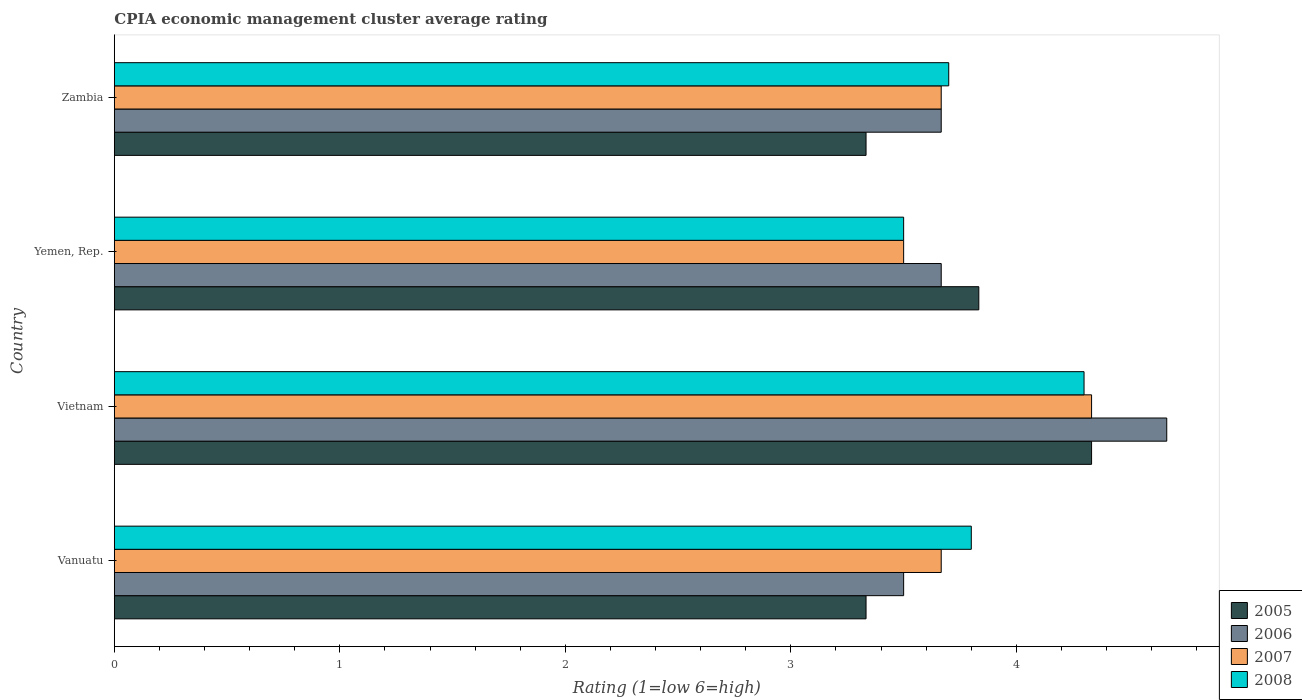Are the number of bars per tick equal to the number of legend labels?
Your response must be concise. Yes. Are the number of bars on each tick of the Y-axis equal?
Offer a terse response. Yes. How many bars are there on the 4th tick from the bottom?
Provide a succinct answer. 4. What is the label of the 3rd group of bars from the top?
Give a very brief answer. Vietnam. In how many cases, is the number of bars for a given country not equal to the number of legend labels?
Provide a short and direct response. 0. What is the CPIA rating in 2006 in Yemen, Rep.?
Offer a terse response. 3.67. Across all countries, what is the maximum CPIA rating in 2008?
Keep it short and to the point. 4.3. Across all countries, what is the minimum CPIA rating in 2006?
Offer a very short reply. 3.5. In which country was the CPIA rating in 2005 maximum?
Give a very brief answer. Vietnam. In which country was the CPIA rating in 2005 minimum?
Give a very brief answer. Vanuatu. What is the total CPIA rating in 2006 in the graph?
Offer a terse response. 15.5. What is the difference between the CPIA rating in 2005 in Yemen, Rep. and that in Zambia?
Make the answer very short. 0.5. What is the difference between the CPIA rating in 2005 in Vietnam and the CPIA rating in 2007 in Vanuatu?
Offer a terse response. 0.67. What is the average CPIA rating in 2007 per country?
Offer a very short reply. 3.79. What is the difference between the CPIA rating in 2005 and CPIA rating in 2008 in Zambia?
Keep it short and to the point. -0.37. In how many countries, is the CPIA rating in 2005 greater than 4.4 ?
Offer a terse response. 0. What is the ratio of the CPIA rating in 2006 in Yemen, Rep. to that in Zambia?
Your answer should be compact. 1. Is the CPIA rating in 2007 in Vietnam less than that in Zambia?
Offer a terse response. No. What is the difference between the highest and the second highest CPIA rating in 2007?
Offer a terse response. 0.67. What is the difference between the highest and the lowest CPIA rating in 2007?
Offer a very short reply. 0.83. Is the sum of the CPIA rating in 2005 in Vanuatu and Yemen, Rep. greater than the maximum CPIA rating in 2007 across all countries?
Your response must be concise. Yes. Is it the case that in every country, the sum of the CPIA rating in 2006 and CPIA rating in 2007 is greater than the sum of CPIA rating in 2008 and CPIA rating in 2005?
Give a very brief answer. No. What does the 2nd bar from the bottom in Yemen, Rep. represents?
Offer a terse response. 2006. Is it the case that in every country, the sum of the CPIA rating in 2008 and CPIA rating in 2006 is greater than the CPIA rating in 2005?
Provide a short and direct response. Yes. Are all the bars in the graph horizontal?
Offer a very short reply. Yes. Does the graph contain any zero values?
Give a very brief answer. No. Where does the legend appear in the graph?
Keep it short and to the point. Bottom right. How are the legend labels stacked?
Give a very brief answer. Vertical. What is the title of the graph?
Ensure brevity in your answer.  CPIA economic management cluster average rating. Does "2008" appear as one of the legend labels in the graph?
Your answer should be compact. Yes. What is the label or title of the X-axis?
Provide a succinct answer. Rating (1=low 6=high). What is the Rating (1=low 6=high) in 2005 in Vanuatu?
Your answer should be very brief. 3.33. What is the Rating (1=low 6=high) in 2006 in Vanuatu?
Keep it short and to the point. 3.5. What is the Rating (1=low 6=high) in 2007 in Vanuatu?
Your answer should be very brief. 3.67. What is the Rating (1=low 6=high) in 2008 in Vanuatu?
Ensure brevity in your answer.  3.8. What is the Rating (1=low 6=high) of 2005 in Vietnam?
Your answer should be compact. 4.33. What is the Rating (1=low 6=high) of 2006 in Vietnam?
Give a very brief answer. 4.67. What is the Rating (1=low 6=high) of 2007 in Vietnam?
Make the answer very short. 4.33. What is the Rating (1=low 6=high) of 2008 in Vietnam?
Your answer should be very brief. 4.3. What is the Rating (1=low 6=high) in 2005 in Yemen, Rep.?
Ensure brevity in your answer.  3.83. What is the Rating (1=low 6=high) of 2006 in Yemen, Rep.?
Offer a very short reply. 3.67. What is the Rating (1=low 6=high) in 2007 in Yemen, Rep.?
Ensure brevity in your answer.  3.5. What is the Rating (1=low 6=high) in 2008 in Yemen, Rep.?
Offer a terse response. 3.5. What is the Rating (1=low 6=high) in 2005 in Zambia?
Your response must be concise. 3.33. What is the Rating (1=low 6=high) in 2006 in Zambia?
Provide a succinct answer. 3.67. What is the Rating (1=low 6=high) in 2007 in Zambia?
Offer a terse response. 3.67. What is the Rating (1=low 6=high) in 2008 in Zambia?
Offer a terse response. 3.7. Across all countries, what is the maximum Rating (1=low 6=high) of 2005?
Offer a very short reply. 4.33. Across all countries, what is the maximum Rating (1=low 6=high) in 2006?
Your answer should be compact. 4.67. Across all countries, what is the maximum Rating (1=low 6=high) in 2007?
Your answer should be very brief. 4.33. Across all countries, what is the maximum Rating (1=low 6=high) of 2008?
Your response must be concise. 4.3. Across all countries, what is the minimum Rating (1=low 6=high) of 2005?
Provide a short and direct response. 3.33. What is the total Rating (1=low 6=high) in 2005 in the graph?
Ensure brevity in your answer.  14.83. What is the total Rating (1=low 6=high) in 2007 in the graph?
Keep it short and to the point. 15.17. What is the difference between the Rating (1=low 6=high) in 2005 in Vanuatu and that in Vietnam?
Provide a short and direct response. -1. What is the difference between the Rating (1=low 6=high) of 2006 in Vanuatu and that in Vietnam?
Your response must be concise. -1.17. What is the difference between the Rating (1=low 6=high) in 2008 in Vanuatu and that in Vietnam?
Give a very brief answer. -0.5. What is the difference between the Rating (1=low 6=high) in 2005 in Vanuatu and that in Yemen, Rep.?
Offer a terse response. -0.5. What is the difference between the Rating (1=low 6=high) of 2006 in Vanuatu and that in Yemen, Rep.?
Ensure brevity in your answer.  -0.17. What is the difference between the Rating (1=low 6=high) of 2007 in Vanuatu and that in Yemen, Rep.?
Ensure brevity in your answer.  0.17. What is the difference between the Rating (1=low 6=high) in 2008 in Vanuatu and that in Yemen, Rep.?
Give a very brief answer. 0.3. What is the difference between the Rating (1=low 6=high) of 2006 in Vanuatu and that in Zambia?
Your answer should be very brief. -0.17. What is the difference between the Rating (1=low 6=high) of 2007 in Vanuatu and that in Zambia?
Offer a very short reply. 0. What is the difference between the Rating (1=low 6=high) of 2005 in Vietnam and that in Yemen, Rep.?
Your response must be concise. 0.5. What is the difference between the Rating (1=low 6=high) of 2006 in Vietnam and that in Zambia?
Make the answer very short. 1. What is the difference between the Rating (1=low 6=high) of 2007 in Vietnam and that in Zambia?
Ensure brevity in your answer.  0.67. What is the difference between the Rating (1=low 6=high) of 2005 in Yemen, Rep. and that in Zambia?
Your answer should be very brief. 0.5. What is the difference between the Rating (1=low 6=high) in 2006 in Yemen, Rep. and that in Zambia?
Your response must be concise. 0. What is the difference between the Rating (1=low 6=high) of 2007 in Yemen, Rep. and that in Zambia?
Ensure brevity in your answer.  -0.17. What is the difference between the Rating (1=low 6=high) in 2005 in Vanuatu and the Rating (1=low 6=high) in 2006 in Vietnam?
Provide a succinct answer. -1.33. What is the difference between the Rating (1=low 6=high) in 2005 in Vanuatu and the Rating (1=low 6=high) in 2007 in Vietnam?
Keep it short and to the point. -1. What is the difference between the Rating (1=low 6=high) of 2005 in Vanuatu and the Rating (1=low 6=high) of 2008 in Vietnam?
Your answer should be very brief. -0.97. What is the difference between the Rating (1=low 6=high) in 2006 in Vanuatu and the Rating (1=low 6=high) in 2008 in Vietnam?
Provide a succinct answer. -0.8. What is the difference between the Rating (1=low 6=high) of 2007 in Vanuatu and the Rating (1=low 6=high) of 2008 in Vietnam?
Make the answer very short. -0.63. What is the difference between the Rating (1=low 6=high) of 2005 in Vanuatu and the Rating (1=low 6=high) of 2006 in Yemen, Rep.?
Your answer should be very brief. -0.33. What is the difference between the Rating (1=low 6=high) of 2005 in Vanuatu and the Rating (1=low 6=high) of 2008 in Yemen, Rep.?
Keep it short and to the point. -0.17. What is the difference between the Rating (1=low 6=high) in 2005 in Vanuatu and the Rating (1=low 6=high) in 2008 in Zambia?
Your answer should be compact. -0.37. What is the difference between the Rating (1=low 6=high) of 2006 in Vanuatu and the Rating (1=low 6=high) of 2008 in Zambia?
Your answer should be compact. -0.2. What is the difference between the Rating (1=low 6=high) of 2007 in Vanuatu and the Rating (1=low 6=high) of 2008 in Zambia?
Keep it short and to the point. -0.03. What is the difference between the Rating (1=low 6=high) of 2005 in Vietnam and the Rating (1=low 6=high) of 2007 in Yemen, Rep.?
Make the answer very short. 0.83. What is the difference between the Rating (1=low 6=high) of 2005 in Vietnam and the Rating (1=low 6=high) of 2008 in Yemen, Rep.?
Ensure brevity in your answer.  0.83. What is the difference between the Rating (1=low 6=high) in 2005 in Vietnam and the Rating (1=low 6=high) in 2006 in Zambia?
Ensure brevity in your answer.  0.67. What is the difference between the Rating (1=low 6=high) in 2005 in Vietnam and the Rating (1=low 6=high) in 2008 in Zambia?
Keep it short and to the point. 0.63. What is the difference between the Rating (1=low 6=high) in 2006 in Vietnam and the Rating (1=low 6=high) in 2008 in Zambia?
Make the answer very short. 0.97. What is the difference between the Rating (1=low 6=high) of 2007 in Vietnam and the Rating (1=low 6=high) of 2008 in Zambia?
Offer a very short reply. 0.63. What is the difference between the Rating (1=low 6=high) of 2005 in Yemen, Rep. and the Rating (1=low 6=high) of 2006 in Zambia?
Offer a very short reply. 0.17. What is the difference between the Rating (1=low 6=high) of 2005 in Yemen, Rep. and the Rating (1=low 6=high) of 2007 in Zambia?
Offer a very short reply. 0.17. What is the difference between the Rating (1=low 6=high) of 2005 in Yemen, Rep. and the Rating (1=low 6=high) of 2008 in Zambia?
Keep it short and to the point. 0.13. What is the difference between the Rating (1=low 6=high) in 2006 in Yemen, Rep. and the Rating (1=low 6=high) in 2008 in Zambia?
Your response must be concise. -0.03. What is the average Rating (1=low 6=high) of 2005 per country?
Keep it short and to the point. 3.71. What is the average Rating (1=low 6=high) in 2006 per country?
Provide a short and direct response. 3.88. What is the average Rating (1=low 6=high) of 2007 per country?
Provide a short and direct response. 3.79. What is the average Rating (1=low 6=high) of 2008 per country?
Your answer should be compact. 3.83. What is the difference between the Rating (1=low 6=high) of 2005 and Rating (1=low 6=high) of 2007 in Vanuatu?
Your response must be concise. -0.33. What is the difference between the Rating (1=low 6=high) of 2005 and Rating (1=low 6=high) of 2008 in Vanuatu?
Make the answer very short. -0.47. What is the difference between the Rating (1=low 6=high) of 2006 and Rating (1=low 6=high) of 2008 in Vanuatu?
Provide a short and direct response. -0.3. What is the difference between the Rating (1=low 6=high) of 2007 and Rating (1=low 6=high) of 2008 in Vanuatu?
Your answer should be very brief. -0.13. What is the difference between the Rating (1=low 6=high) of 2005 and Rating (1=low 6=high) of 2007 in Vietnam?
Offer a terse response. 0. What is the difference between the Rating (1=low 6=high) in 2006 and Rating (1=low 6=high) in 2007 in Vietnam?
Offer a very short reply. 0.33. What is the difference between the Rating (1=low 6=high) of 2006 and Rating (1=low 6=high) of 2008 in Vietnam?
Your answer should be very brief. 0.37. What is the difference between the Rating (1=low 6=high) in 2005 and Rating (1=low 6=high) in 2007 in Yemen, Rep.?
Your answer should be very brief. 0.33. What is the difference between the Rating (1=low 6=high) in 2005 and Rating (1=low 6=high) in 2008 in Yemen, Rep.?
Make the answer very short. 0.33. What is the difference between the Rating (1=low 6=high) of 2006 and Rating (1=low 6=high) of 2007 in Yemen, Rep.?
Provide a short and direct response. 0.17. What is the difference between the Rating (1=low 6=high) of 2006 and Rating (1=low 6=high) of 2008 in Yemen, Rep.?
Your answer should be compact. 0.17. What is the difference between the Rating (1=low 6=high) of 2007 and Rating (1=low 6=high) of 2008 in Yemen, Rep.?
Keep it short and to the point. 0. What is the difference between the Rating (1=low 6=high) in 2005 and Rating (1=low 6=high) in 2006 in Zambia?
Offer a terse response. -0.33. What is the difference between the Rating (1=low 6=high) in 2005 and Rating (1=low 6=high) in 2007 in Zambia?
Provide a short and direct response. -0.33. What is the difference between the Rating (1=low 6=high) of 2005 and Rating (1=low 6=high) of 2008 in Zambia?
Make the answer very short. -0.37. What is the difference between the Rating (1=low 6=high) in 2006 and Rating (1=low 6=high) in 2008 in Zambia?
Provide a short and direct response. -0.03. What is the difference between the Rating (1=low 6=high) in 2007 and Rating (1=low 6=high) in 2008 in Zambia?
Ensure brevity in your answer.  -0.03. What is the ratio of the Rating (1=low 6=high) of 2005 in Vanuatu to that in Vietnam?
Provide a succinct answer. 0.77. What is the ratio of the Rating (1=low 6=high) of 2006 in Vanuatu to that in Vietnam?
Make the answer very short. 0.75. What is the ratio of the Rating (1=low 6=high) in 2007 in Vanuatu to that in Vietnam?
Give a very brief answer. 0.85. What is the ratio of the Rating (1=low 6=high) of 2008 in Vanuatu to that in Vietnam?
Your answer should be very brief. 0.88. What is the ratio of the Rating (1=low 6=high) of 2005 in Vanuatu to that in Yemen, Rep.?
Your answer should be very brief. 0.87. What is the ratio of the Rating (1=low 6=high) in 2006 in Vanuatu to that in Yemen, Rep.?
Provide a succinct answer. 0.95. What is the ratio of the Rating (1=low 6=high) of 2007 in Vanuatu to that in Yemen, Rep.?
Offer a terse response. 1.05. What is the ratio of the Rating (1=low 6=high) in 2008 in Vanuatu to that in Yemen, Rep.?
Offer a very short reply. 1.09. What is the ratio of the Rating (1=low 6=high) of 2006 in Vanuatu to that in Zambia?
Ensure brevity in your answer.  0.95. What is the ratio of the Rating (1=low 6=high) of 2005 in Vietnam to that in Yemen, Rep.?
Ensure brevity in your answer.  1.13. What is the ratio of the Rating (1=low 6=high) in 2006 in Vietnam to that in Yemen, Rep.?
Your response must be concise. 1.27. What is the ratio of the Rating (1=low 6=high) of 2007 in Vietnam to that in Yemen, Rep.?
Make the answer very short. 1.24. What is the ratio of the Rating (1=low 6=high) of 2008 in Vietnam to that in Yemen, Rep.?
Your answer should be compact. 1.23. What is the ratio of the Rating (1=low 6=high) in 2005 in Vietnam to that in Zambia?
Keep it short and to the point. 1.3. What is the ratio of the Rating (1=low 6=high) of 2006 in Vietnam to that in Zambia?
Your response must be concise. 1.27. What is the ratio of the Rating (1=low 6=high) in 2007 in Vietnam to that in Zambia?
Offer a very short reply. 1.18. What is the ratio of the Rating (1=low 6=high) in 2008 in Vietnam to that in Zambia?
Give a very brief answer. 1.16. What is the ratio of the Rating (1=low 6=high) of 2005 in Yemen, Rep. to that in Zambia?
Give a very brief answer. 1.15. What is the ratio of the Rating (1=low 6=high) of 2007 in Yemen, Rep. to that in Zambia?
Your response must be concise. 0.95. What is the ratio of the Rating (1=low 6=high) of 2008 in Yemen, Rep. to that in Zambia?
Ensure brevity in your answer.  0.95. What is the difference between the highest and the second highest Rating (1=low 6=high) of 2006?
Your response must be concise. 1. What is the difference between the highest and the second highest Rating (1=low 6=high) of 2007?
Offer a terse response. 0.67. 